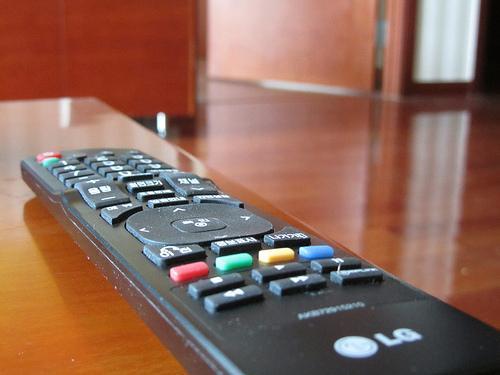How many doors are open?
Give a very brief answer. 1. How many red button are visible on the remote control?
Give a very brief answer. 2. How many green buttons are on the remote control?
Give a very brief answer. 2. 